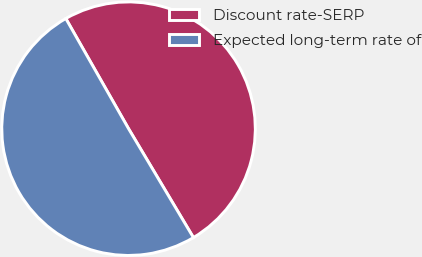Convert chart to OTSL. <chart><loc_0><loc_0><loc_500><loc_500><pie_chart><fcel>Discount rate-SERP<fcel>Expected long-term rate of<nl><fcel>49.69%<fcel>50.31%<nl></chart> 